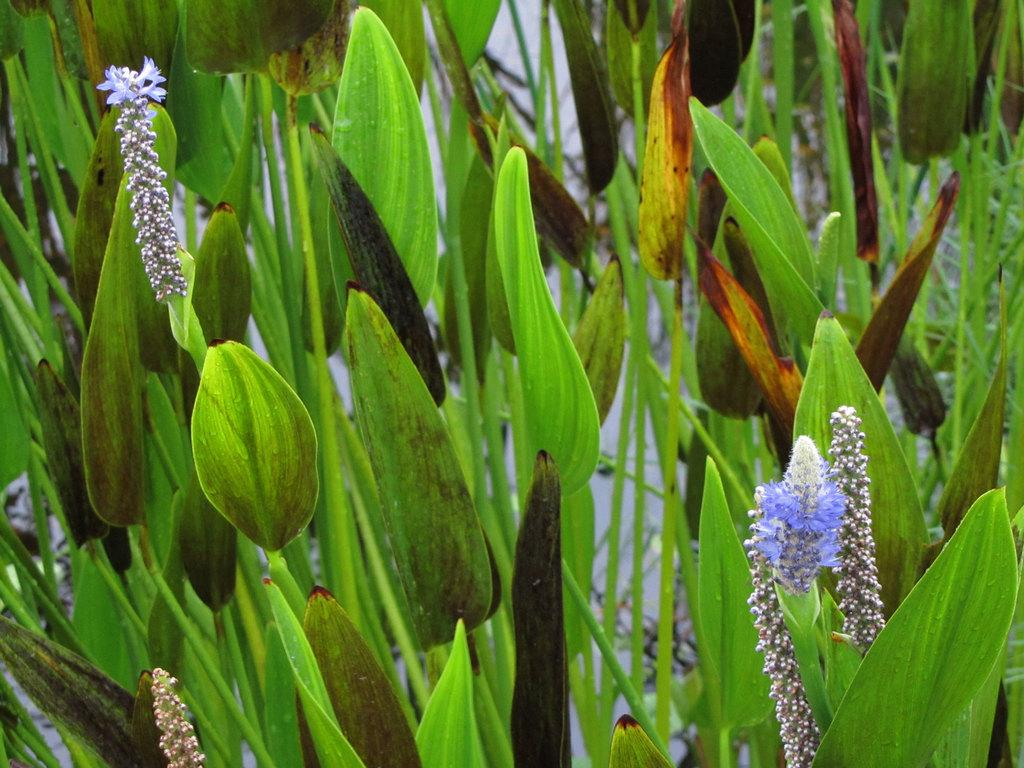What type of living organisms can be seen in the image? Plants can be seen in the image. What specific features can be observed on the plants? The plants have flowers and leaves. What type of pickle is being used to water the plants in the image? There is no pickle present in the image, and plants are not typically watered with pickles. 